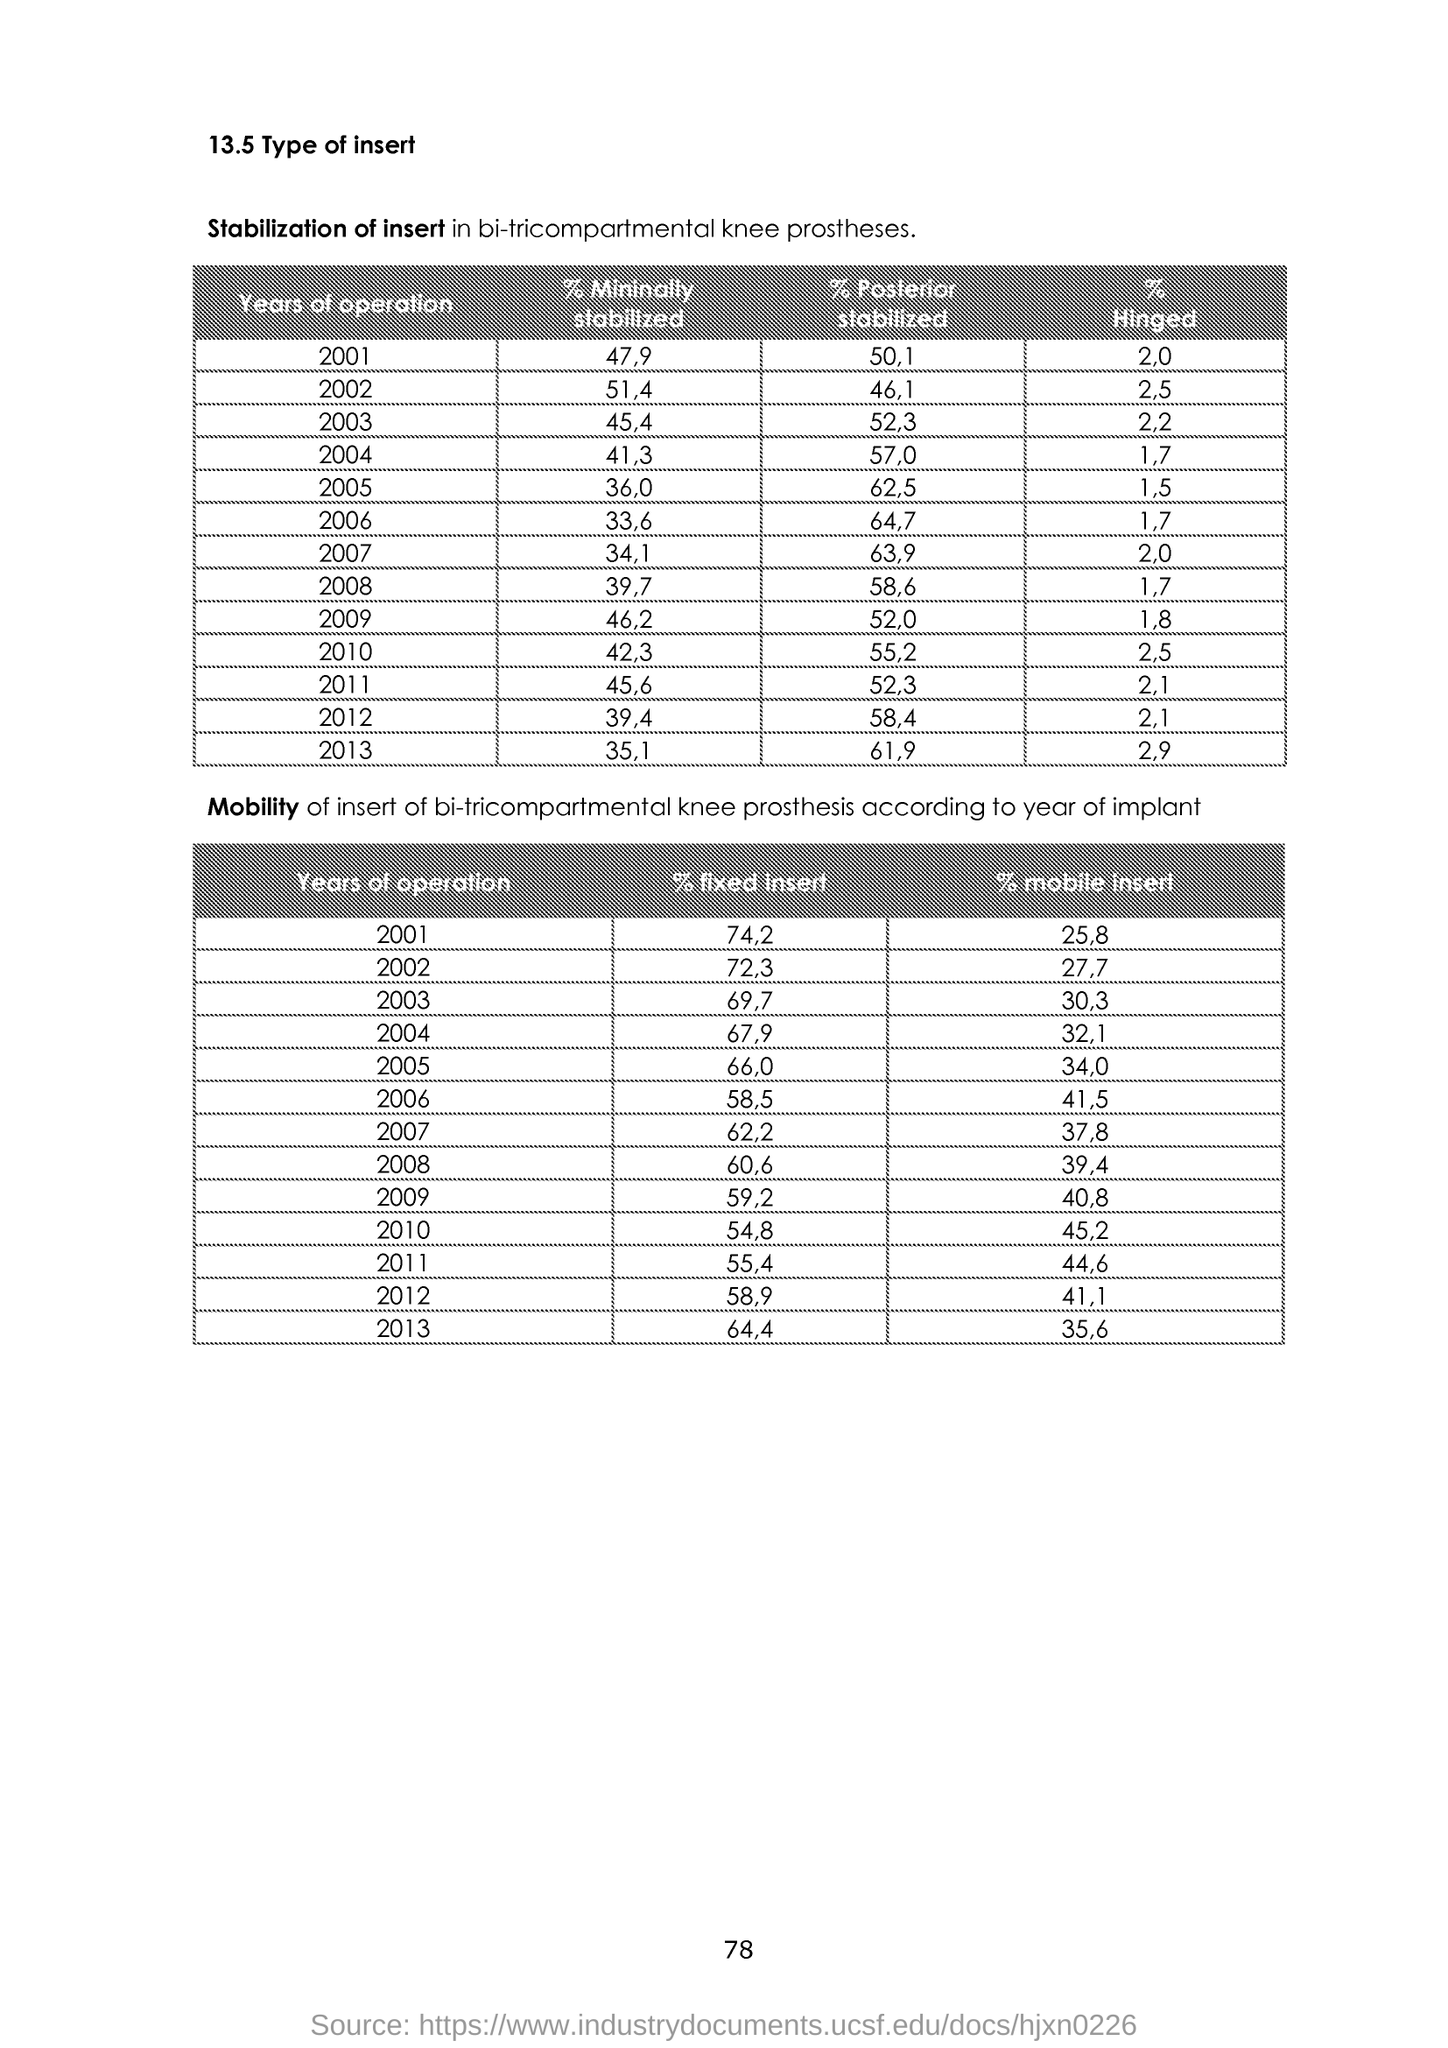What is the % Mininally stabilized for 2001?
Keep it short and to the point. 47,9. What is the % Mininally stabilized for 2002?
Provide a succinct answer. 51,4. What is the % Mininally stabilized for 2003?
Keep it short and to the point. 45,4. What is the % Mininally stabilized for 2004?
Make the answer very short. 41,3. What is the % Mininally stabilized for 2005?
Offer a very short reply. 36,0. What is the % Mininally stabilized for 2006?
Ensure brevity in your answer.  33,6. What is the % Mininally stabilized for 2007?
Provide a succinct answer. 34,1. What is the % Mininally stabilized for 2008?
Offer a terse response. 39,7. What is the % Mininally stabilized for 2009?
Keep it short and to the point. 46,2. What is the % Mininally stabilized for 2010?
Offer a terse response. 42,3. 